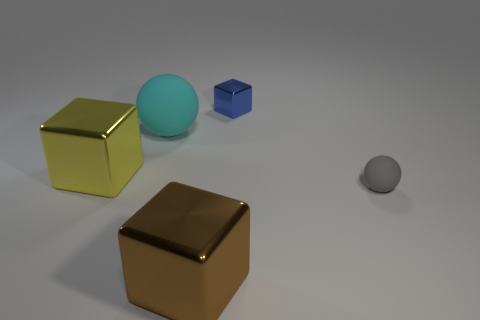Subtract all big cubes. How many cubes are left? 1 Subtract all brown cubes. How many cubes are left? 2 Subtract 1 cubes. How many cubes are left? 2 Add 3 small brown objects. How many objects exist? 8 Subtract all cyan balls. Subtract all purple cylinders. How many balls are left? 1 Subtract all blue cubes. How many cyan balls are left? 1 Subtract all blue metallic objects. Subtract all large cyan rubber balls. How many objects are left? 3 Add 1 big yellow blocks. How many big yellow blocks are left? 2 Add 1 small things. How many small things exist? 3 Subtract 0 gray cylinders. How many objects are left? 5 